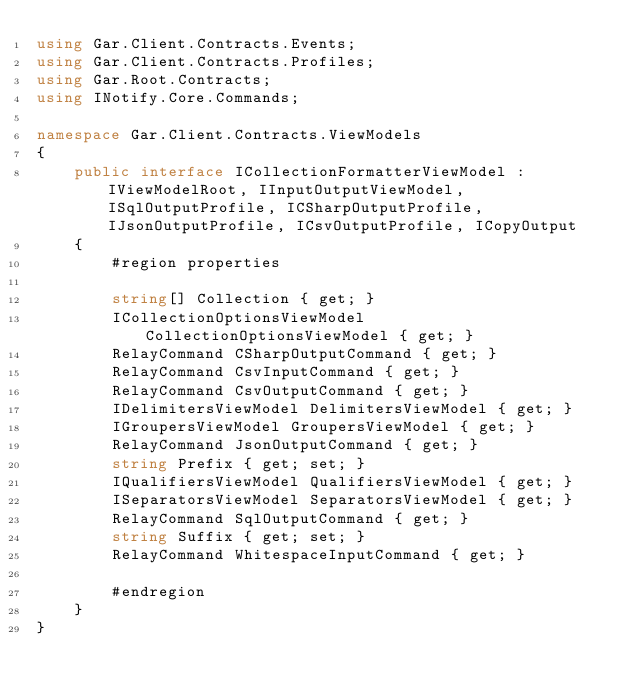<code> <loc_0><loc_0><loc_500><loc_500><_C#_>using Gar.Client.Contracts.Events;
using Gar.Client.Contracts.Profiles;
using Gar.Root.Contracts;
using INotify.Core.Commands;

namespace Gar.Client.Contracts.ViewModels
{
    public interface ICollectionFormatterViewModel : IViewModelRoot, IInputOutputViewModel, ISqlOutputProfile, ICSharpOutputProfile, IJsonOutputProfile, ICsvOutputProfile, ICopyOutput
    {
        #region properties

        string[] Collection { get; }
        ICollectionOptionsViewModel CollectionOptionsViewModel { get; }
        RelayCommand CSharpOutputCommand { get; }
        RelayCommand CsvInputCommand { get; }
        RelayCommand CsvOutputCommand { get; }
        IDelimitersViewModel DelimitersViewModel { get; }
        IGroupersViewModel GroupersViewModel { get; }
        RelayCommand JsonOutputCommand { get; }
        string Prefix { get; set; }
        IQualifiersViewModel QualifiersViewModel { get; }
        ISeparatorsViewModel SeparatorsViewModel { get; }
        RelayCommand SqlOutputCommand { get; }
        string Suffix { get; set; }
        RelayCommand WhitespaceInputCommand { get; }

        #endregion
    }
}
</code> 